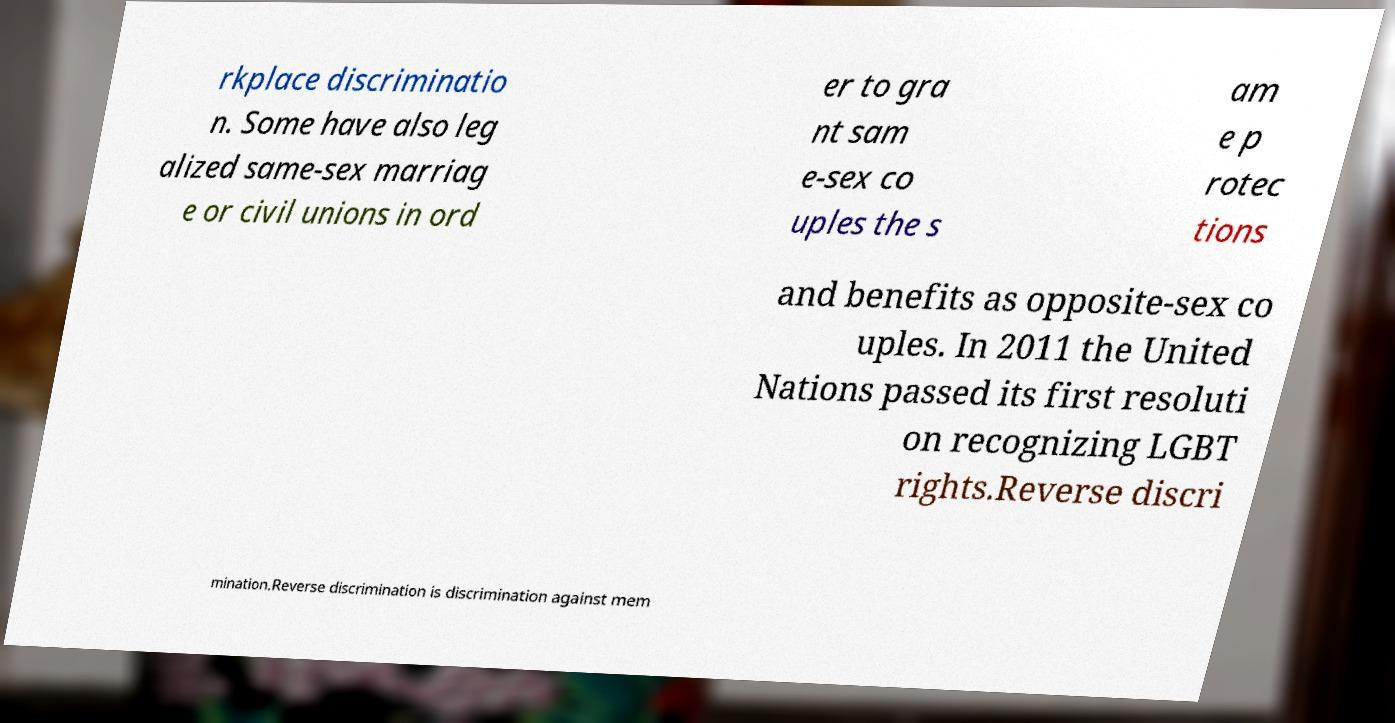Please read and relay the text visible in this image. What does it say? rkplace discriminatio n. Some have also leg alized same-sex marriag e or civil unions in ord er to gra nt sam e-sex co uples the s am e p rotec tions and benefits as opposite-sex co uples. In 2011 the United Nations passed its first resoluti on recognizing LGBT rights.Reverse discri mination.Reverse discrimination is discrimination against mem 